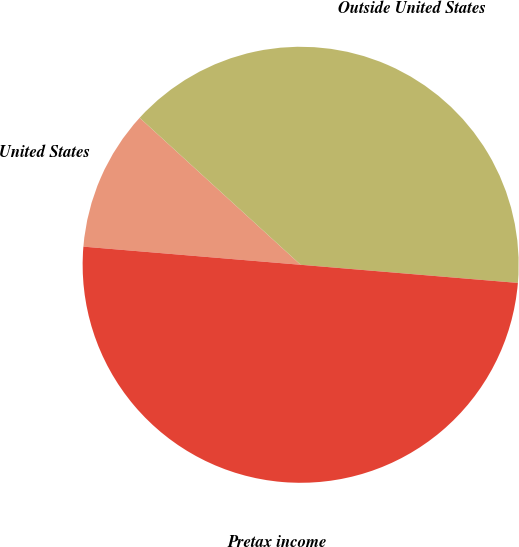Convert chart to OTSL. <chart><loc_0><loc_0><loc_500><loc_500><pie_chart><fcel>United States<fcel>Outside United States<fcel>Pretax income<nl><fcel>10.45%<fcel>39.55%<fcel>50.0%<nl></chart> 